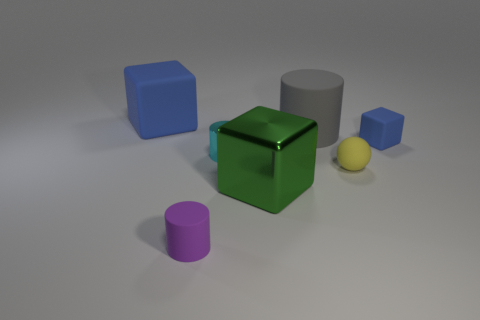Subtract all small rubber cylinders. How many cylinders are left? 2 Subtract all purple cylinders. How many cylinders are left? 2 Subtract all balls. How many objects are left? 6 Subtract all small red metallic balls. Subtract all cylinders. How many objects are left? 4 Add 3 blue blocks. How many blue blocks are left? 5 Add 7 small green blocks. How many small green blocks exist? 7 Add 2 red blocks. How many objects exist? 9 Subtract 0 purple balls. How many objects are left? 7 Subtract 3 cylinders. How many cylinders are left? 0 Subtract all cyan cylinders. Subtract all red cubes. How many cylinders are left? 2 